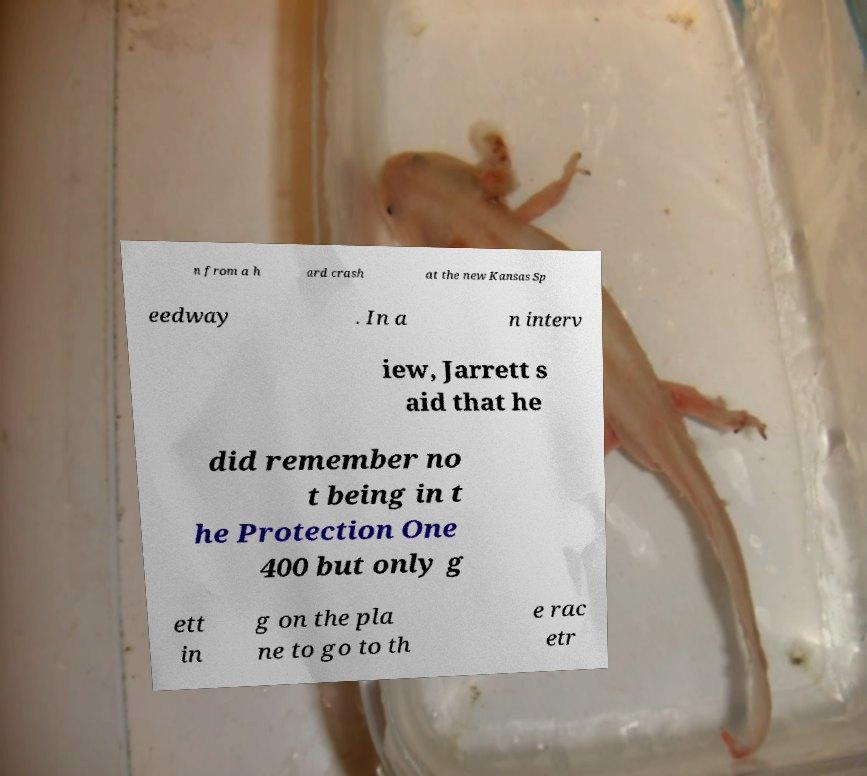What messages or text are displayed in this image? I need them in a readable, typed format. n from a h ard crash at the new Kansas Sp eedway . In a n interv iew, Jarrett s aid that he did remember no t being in t he Protection One 400 but only g ett in g on the pla ne to go to th e rac etr 